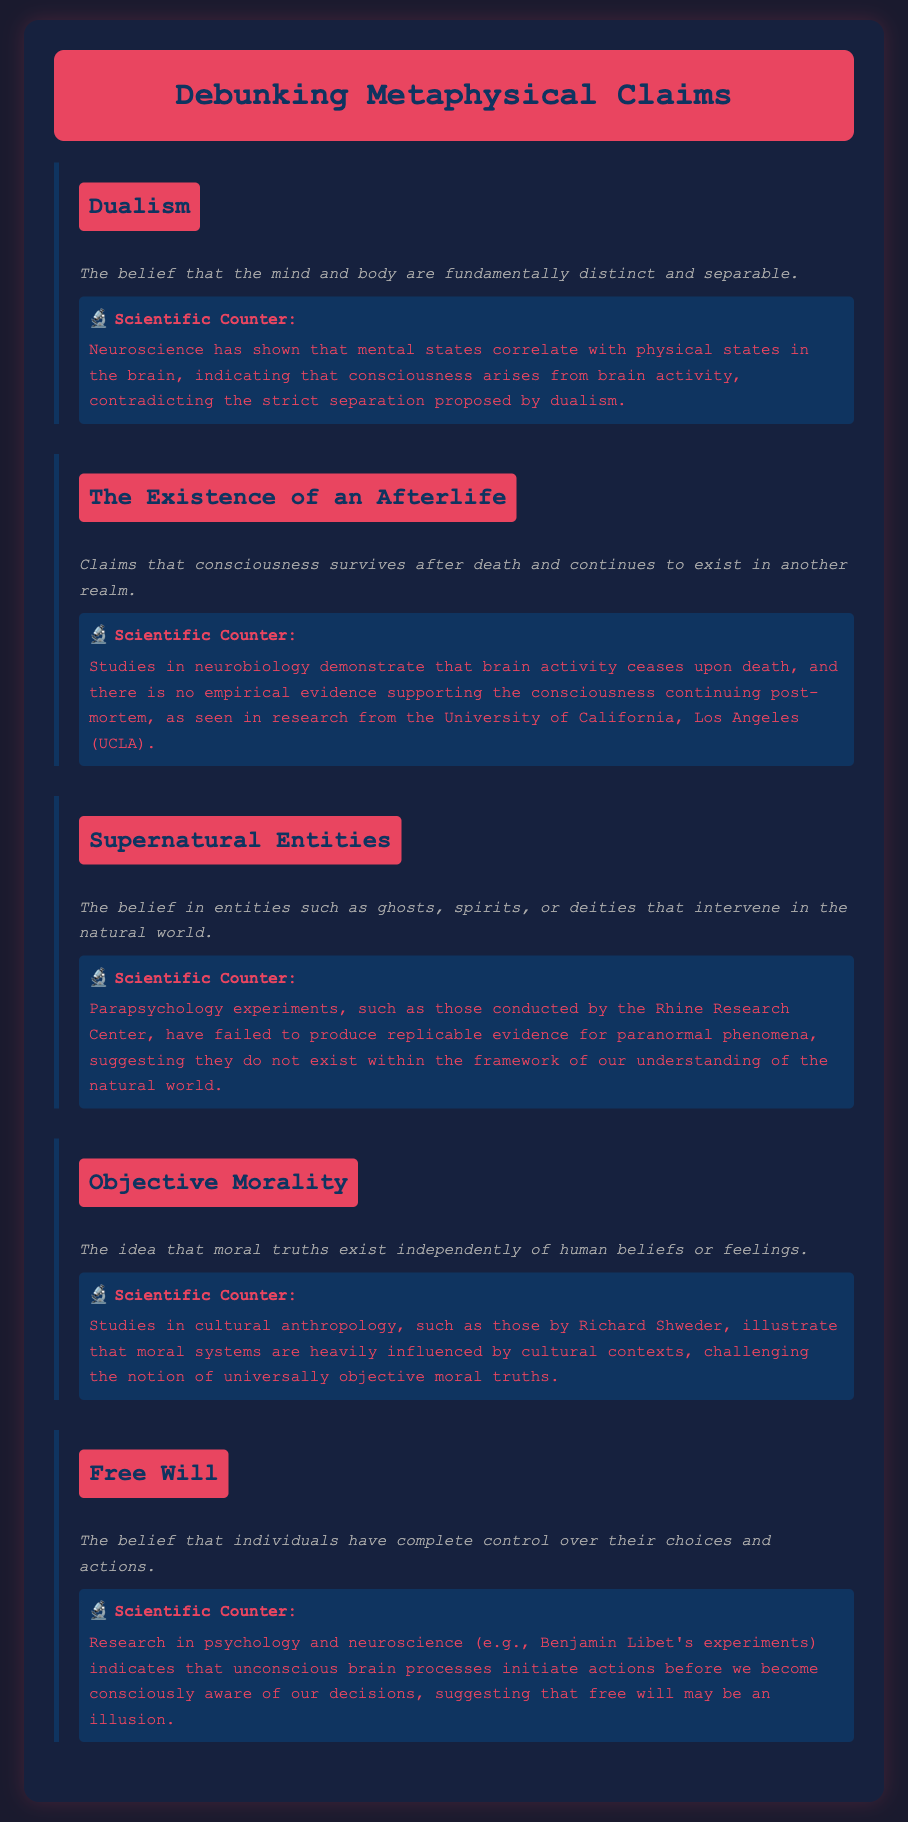What is the belief that the mind and body are fundamentally distinct? This information is found under the Dualism section of the document, which defines it clearly.
Answer: Dualism What scientific evidence counters the existence of an afterlife? The counter claim section for The Existence of an Afterlife provides evidence from neurobiology and UCLA research.
Answer: Brain activity ceases Which research center conducted experiments on paranormal phenomena? This information is located in the Supernatural Entities section, which names the specific research center.
Answer: Rhine Research Center What is challenged by studies in cultural anthropology concerning morality? The Objective Morality section discusses this challenge based on research by Richard Shweder.
Answer: Universally objective moral truths What do Benjamin Libet's experiments suggest about free will? The counter in the Free Will section provides a brief explanation about the implications of these experiments on free will.
Answer: An illusion What color is used for the background of the page? The style section of the HTML document specifies the background color for the body.
Answer: Dark blue How many metaphysical assertions are covered in the document? By counting the distinct assertion sections, we can identify the total number of assertions made.
Answer: Five What does the description of Dualism emphasize? The description section under Dualism highlights the essence of this metaphysical belief explicitly.
Answer: Distinct and separable 